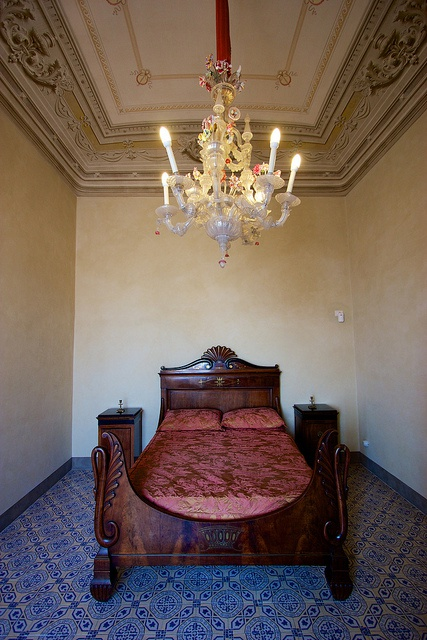Describe the objects in this image and their specific colors. I can see a bed in black, maroon, and brown tones in this image. 